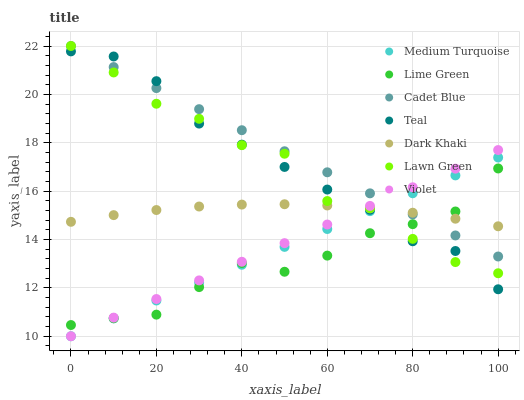Does Lime Green have the minimum area under the curve?
Answer yes or no. Yes. Does Cadet Blue have the maximum area under the curve?
Answer yes or no. Yes. Does Medium Turquoise have the minimum area under the curve?
Answer yes or no. No. Does Medium Turquoise have the maximum area under the curve?
Answer yes or no. No. Is Medium Turquoise the smoothest?
Answer yes or no. Yes. Is Lawn Green the roughest?
Answer yes or no. Yes. Is Cadet Blue the smoothest?
Answer yes or no. No. Is Cadet Blue the roughest?
Answer yes or no. No. Does Medium Turquoise have the lowest value?
Answer yes or no. Yes. Does Cadet Blue have the lowest value?
Answer yes or no. No. Does Cadet Blue have the highest value?
Answer yes or no. Yes. Does Medium Turquoise have the highest value?
Answer yes or no. No. Does Dark Khaki intersect Teal?
Answer yes or no. Yes. Is Dark Khaki less than Teal?
Answer yes or no. No. Is Dark Khaki greater than Teal?
Answer yes or no. No. 